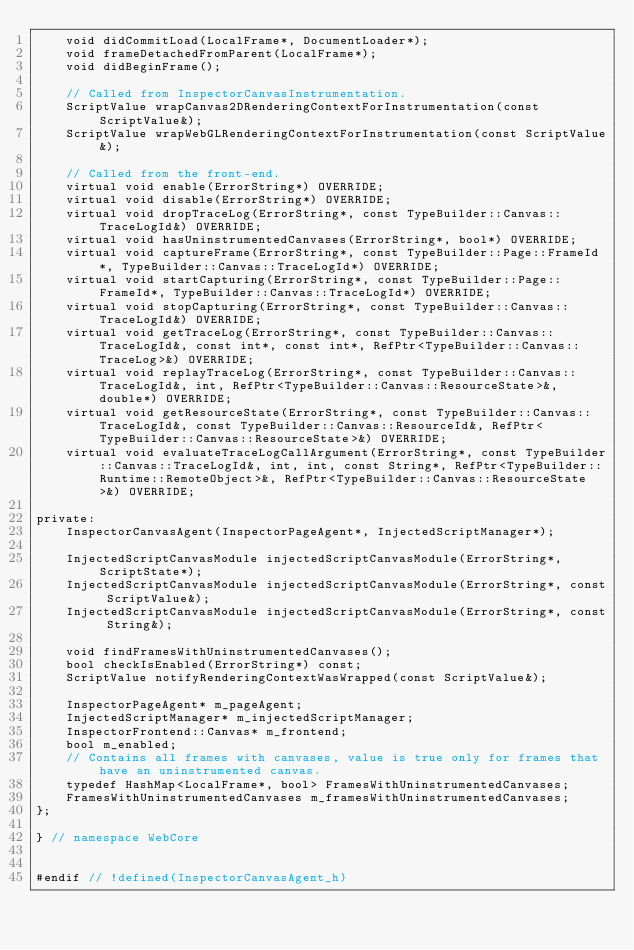<code> <loc_0><loc_0><loc_500><loc_500><_C_>    void didCommitLoad(LocalFrame*, DocumentLoader*);
    void frameDetachedFromParent(LocalFrame*);
    void didBeginFrame();

    // Called from InspectorCanvasInstrumentation.
    ScriptValue wrapCanvas2DRenderingContextForInstrumentation(const ScriptValue&);
    ScriptValue wrapWebGLRenderingContextForInstrumentation(const ScriptValue&);

    // Called from the front-end.
    virtual void enable(ErrorString*) OVERRIDE;
    virtual void disable(ErrorString*) OVERRIDE;
    virtual void dropTraceLog(ErrorString*, const TypeBuilder::Canvas::TraceLogId&) OVERRIDE;
    virtual void hasUninstrumentedCanvases(ErrorString*, bool*) OVERRIDE;
    virtual void captureFrame(ErrorString*, const TypeBuilder::Page::FrameId*, TypeBuilder::Canvas::TraceLogId*) OVERRIDE;
    virtual void startCapturing(ErrorString*, const TypeBuilder::Page::FrameId*, TypeBuilder::Canvas::TraceLogId*) OVERRIDE;
    virtual void stopCapturing(ErrorString*, const TypeBuilder::Canvas::TraceLogId&) OVERRIDE;
    virtual void getTraceLog(ErrorString*, const TypeBuilder::Canvas::TraceLogId&, const int*, const int*, RefPtr<TypeBuilder::Canvas::TraceLog>&) OVERRIDE;
    virtual void replayTraceLog(ErrorString*, const TypeBuilder::Canvas::TraceLogId&, int, RefPtr<TypeBuilder::Canvas::ResourceState>&, double*) OVERRIDE;
    virtual void getResourceState(ErrorString*, const TypeBuilder::Canvas::TraceLogId&, const TypeBuilder::Canvas::ResourceId&, RefPtr<TypeBuilder::Canvas::ResourceState>&) OVERRIDE;
    virtual void evaluateTraceLogCallArgument(ErrorString*, const TypeBuilder::Canvas::TraceLogId&, int, int, const String*, RefPtr<TypeBuilder::Runtime::RemoteObject>&, RefPtr<TypeBuilder::Canvas::ResourceState>&) OVERRIDE;

private:
    InspectorCanvasAgent(InspectorPageAgent*, InjectedScriptManager*);

    InjectedScriptCanvasModule injectedScriptCanvasModule(ErrorString*, ScriptState*);
    InjectedScriptCanvasModule injectedScriptCanvasModule(ErrorString*, const ScriptValue&);
    InjectedScriptCanvasModule injectedScriptCanvasModule(ErrorString*, const String&);

    void findFramesWithUninstrumentedCanvases();
    bool checkIsEnabled(ErrorString*) const;
    ScriptValue notifyRenderingContextWasWrapped(const ScriptValue&);

    InspectorPageAgent* m_pageAgent;
    InjectedScriptManager* m_injectedScriptManager;
    InspectorFrontend::Canvas* m_frontend;
    bool m_enabled;
    // Contains all frames with canvases, value is true only for frames that have an uninstrumented canvas.
    typedef HashMap<LocalFrame*, bool> FramesWithUninstrumentedCanvases;
    FramesWithUninstrumentedCanvases m_framesWithUninstrumentedCanvases;
};

} // namespace WebCore


#endif // !defined(InspectorCanvasAgent_h)
</code> 